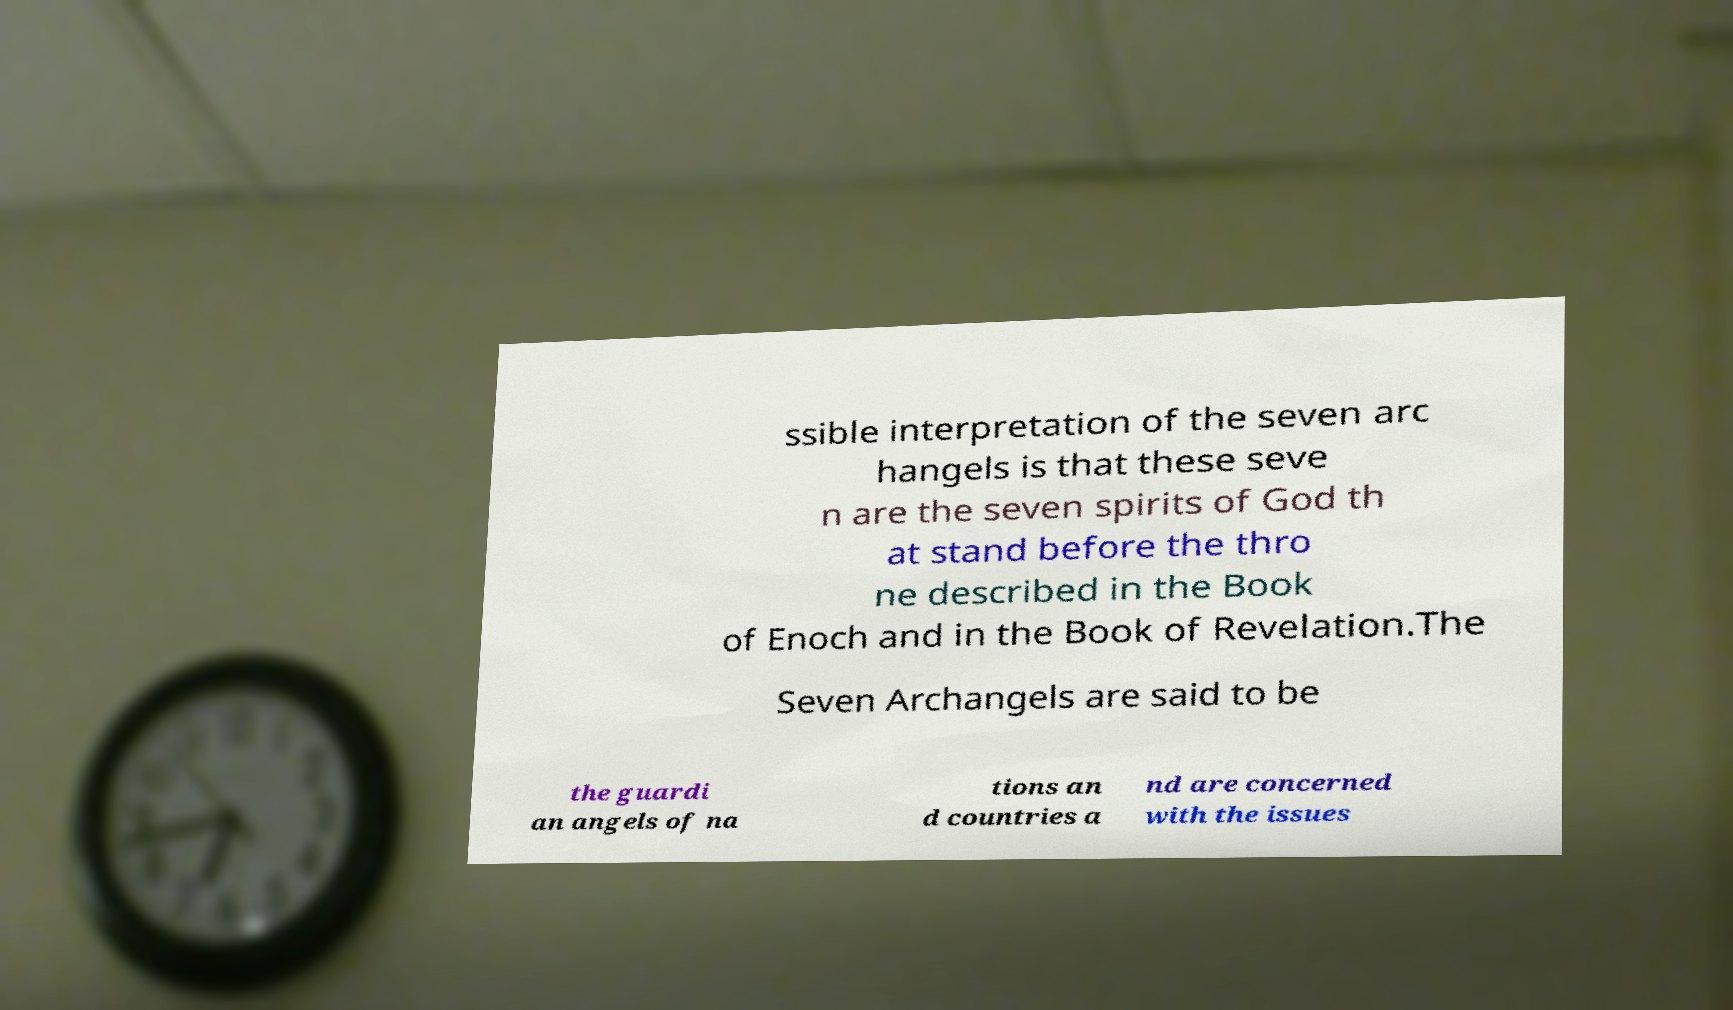Please identify and transcribe the text found in this image. ssible interpretation of the seven arc hangels is that these seve n are the seven spirits of God th at stand before the thro ne described in the Book of Enoch and in the Book of Revelation.The Seven Archangels are said to be the guardi an angels of na tions an d countries a nd are concerned with the issues 